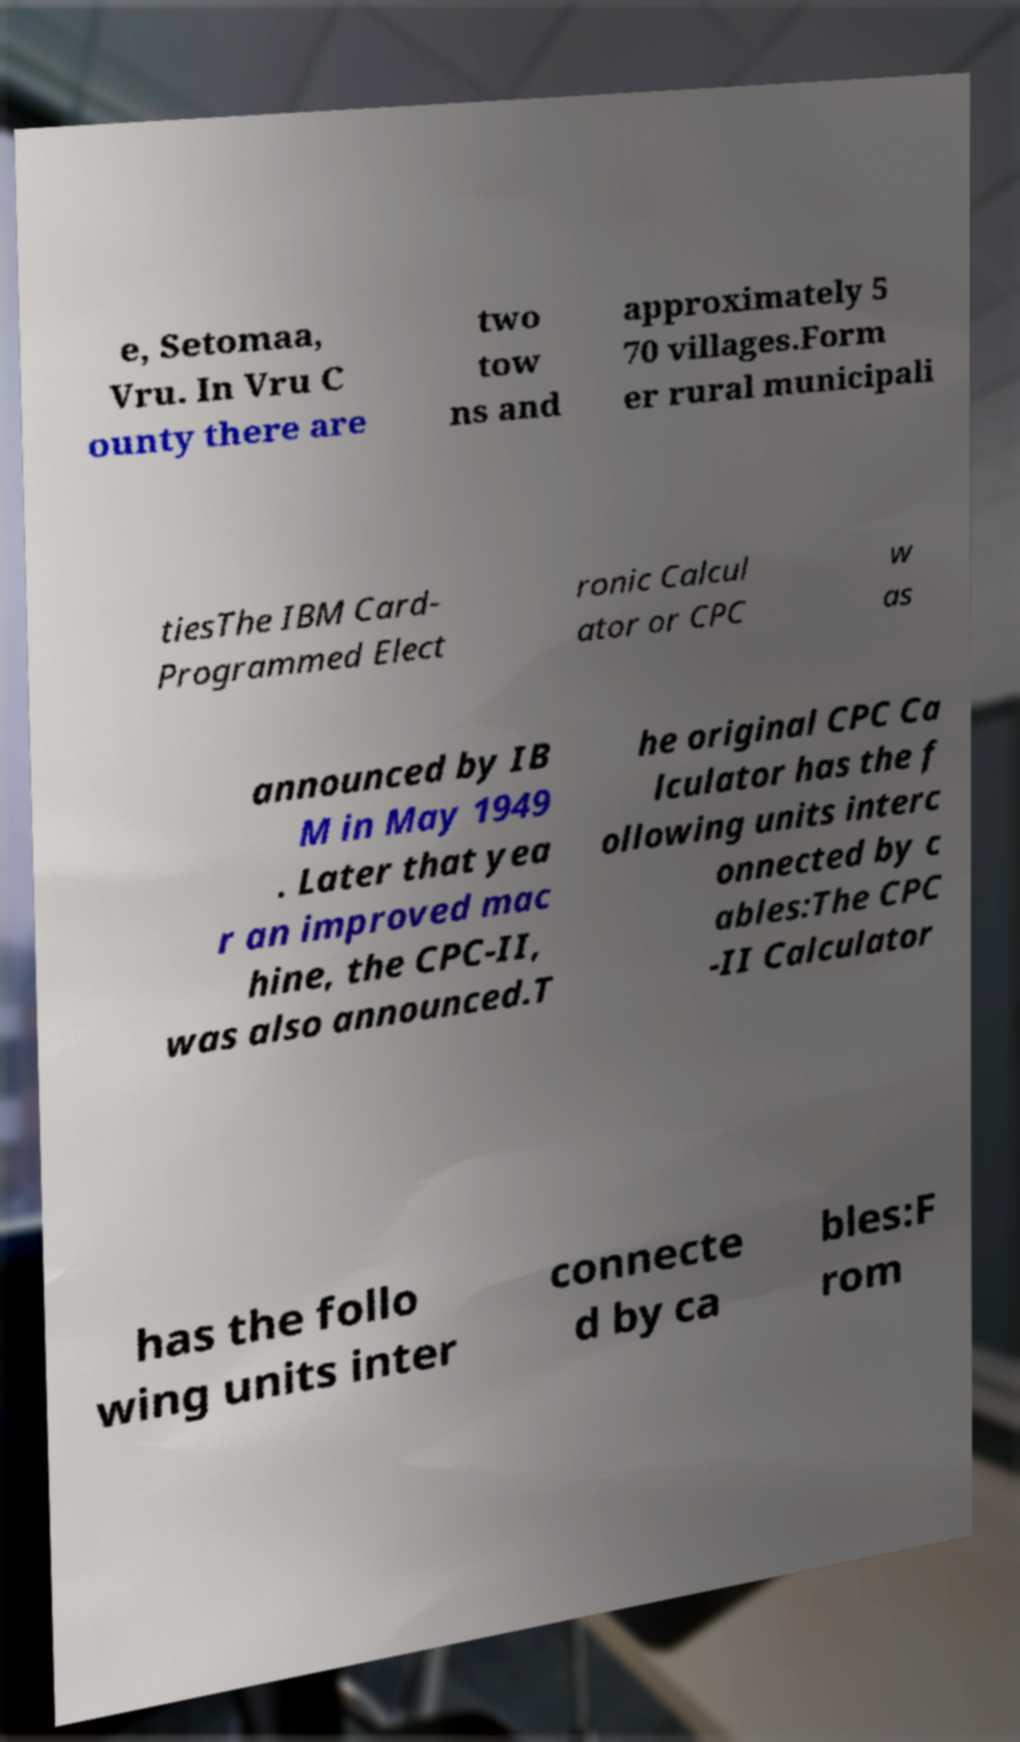I need the written content from this picture converted into text. Can you do that? e, Setomaa, Vru. In Vru C ounty there are two tow ns and approximately 5 70 villages.Form er rural municipali tiesThe IBM Card- Programmed Elect ronic Calcul ator or CPC w as announced by IB M in May 1949 . Later that yea r an improved mac hine, the CPC-II, was also announced.T he original CPC Ca lculator has the f ollowing units interc onnected by c ables:The CPC -II Calculator has the follo wing units inter connecte d by ca bles:F rom 